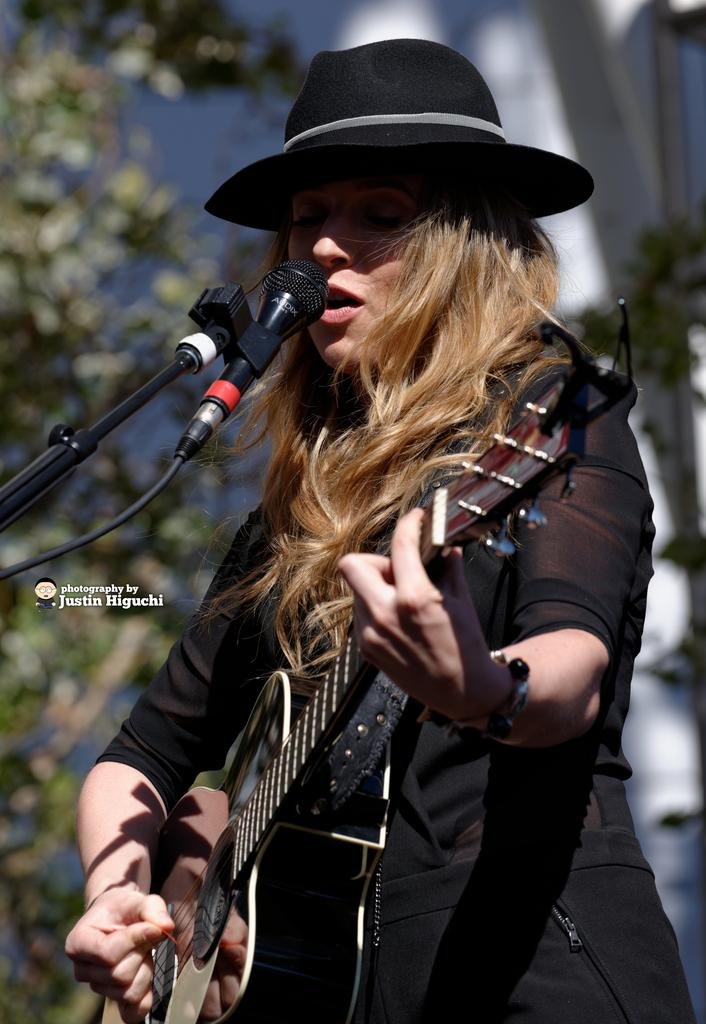Who is the main subject in the image? There is a woman in the image. What is the woman wearing? The woman is wearing a black dress. What is the woman doing in the image? The woman is playing a guitar and singing. What is placed in front of her? There is a microphone placed in front of her. What can be seen in the background of the image? There are trees and buildings in the background of the image. Where is the throne located in the image? There is no throne present in the image. What riddle does the woman solve while playing the guitar? There is no riddle mentioned or depicted in the image. 